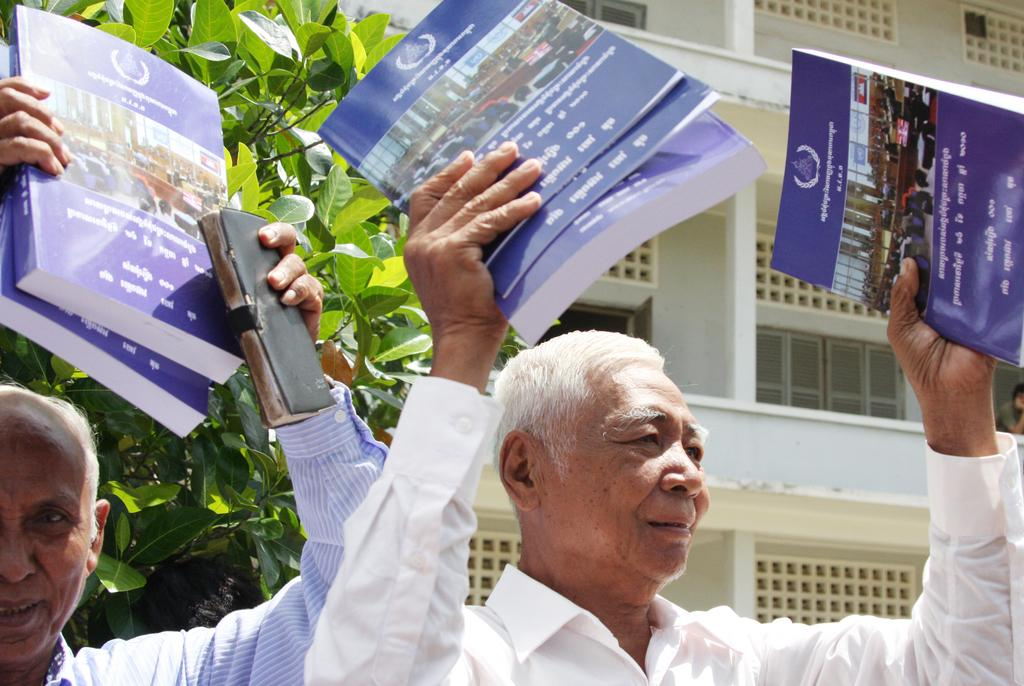How many men are present in the image? There are 2 men in the image. What are the men doing in the image? The men are standing in the image. What objects are the men holding in the image? The men are holding books in the image. What can be seen in the background of the image? There is a tree and a building in the background of the image. What type of chicken can be seen in the image? There is no chicken present in the image. What is the men's comparison of the books they are holding? The image does not provide any information about the men's comparison of the books they are holding. What is the cause of the thunder in the image? There is no thunder present in the image. 